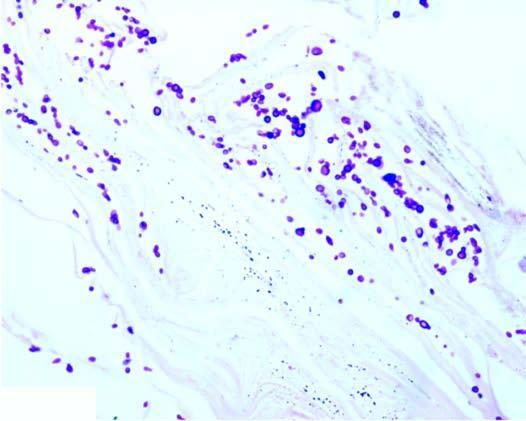what does the stratum corneum around the hair follicle show?
Answer the question using a single word or phrase. Presence of numerous arthrospores and hyphae 